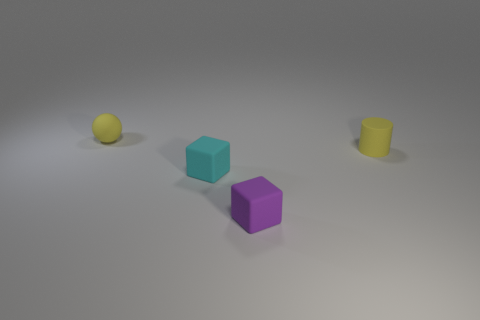Add 1 tiny cyan rubber objects. How many objects exist? 5 Subtract all cylinders. How many objects are left? 3 Subtract 1 cyan cubes. How many objects are left? 3 Subtract all small gray things. Subtract all tiny purple blocks. How many objects are left? 3 Add 1 tiny spheres. How many tiny spheres are left? 2 Add 2 tiny green metal objects. How many tiny green metal objects exist? 2 